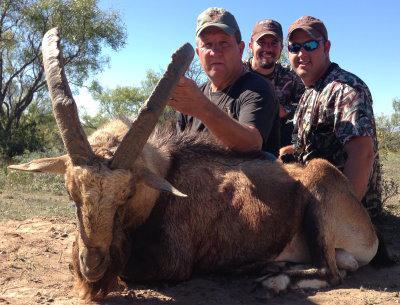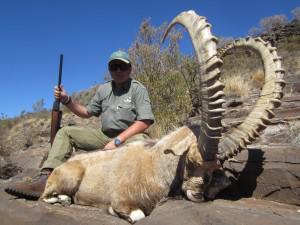The first image is the image on the left, the second image is the image on the right. Given the left and right images, does the statement "In one of the images there is one man holding a rifle and posing in front of a large ram." hold true? Answer yes or no. Yes. The first image is the image on the left, the second image is the image on the right. Given the left and right images, does the statement "There are two hunters with two horned animals." hold true? Answer yes or no. No. 